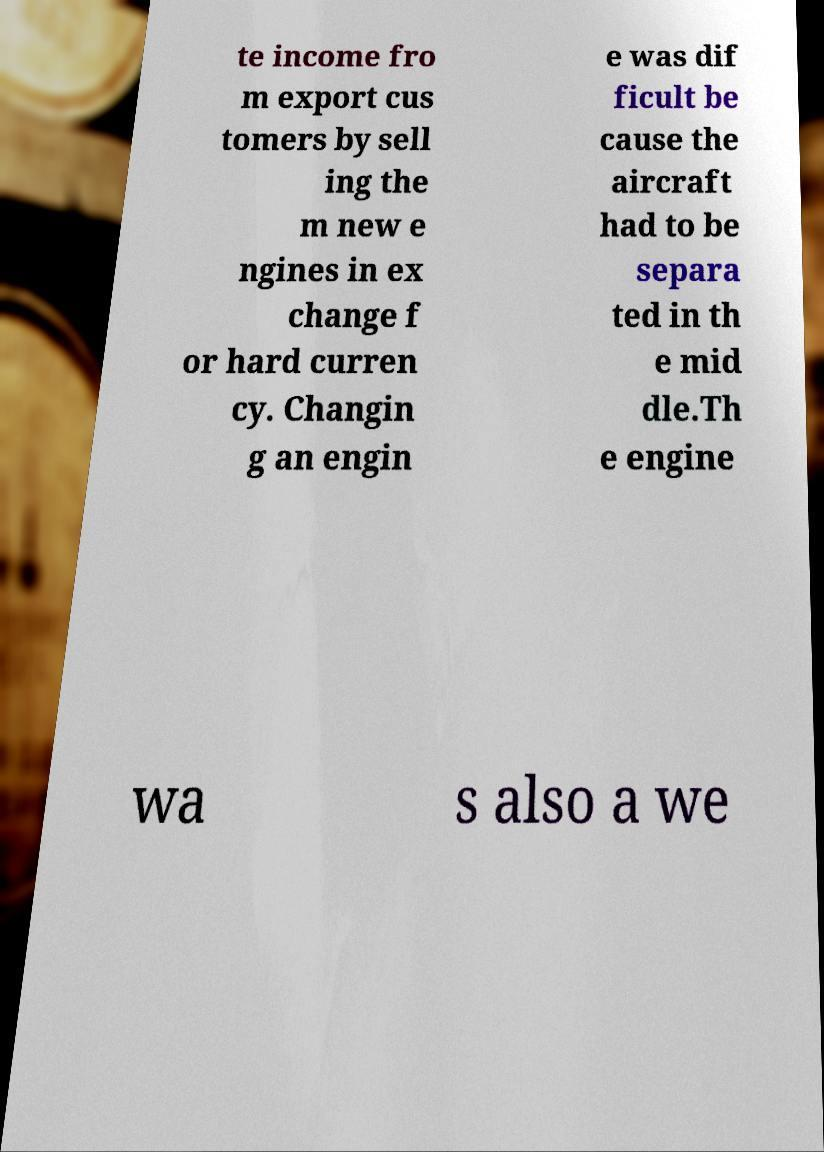Please read and relay the text visible in this image. What does it say? te income fro m export cus tomers by sell ing the m new e ngines in ex change f or hard curren cy. Changin g an engin e was dif ficult be cause the aircraft had to be separa ted in th e mid dle.Th e engine wa s also a we 